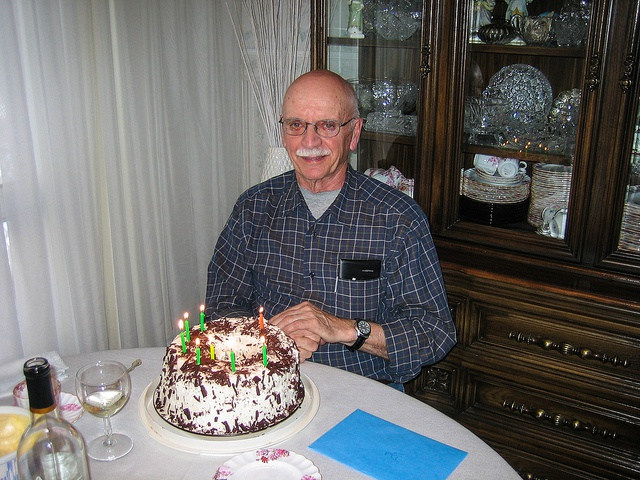Describe the objects in this image and their specific colors. I can see people in darkgray, black, gray, and brown tones, dining table in darkgray, lightgray, and gray tones, cake in darkgray, white, maroon, and brown tones, bottle in darkgray, gray, black, and tan tones, and wine glass in darkgray, lightgray, and gray tones in this image. 